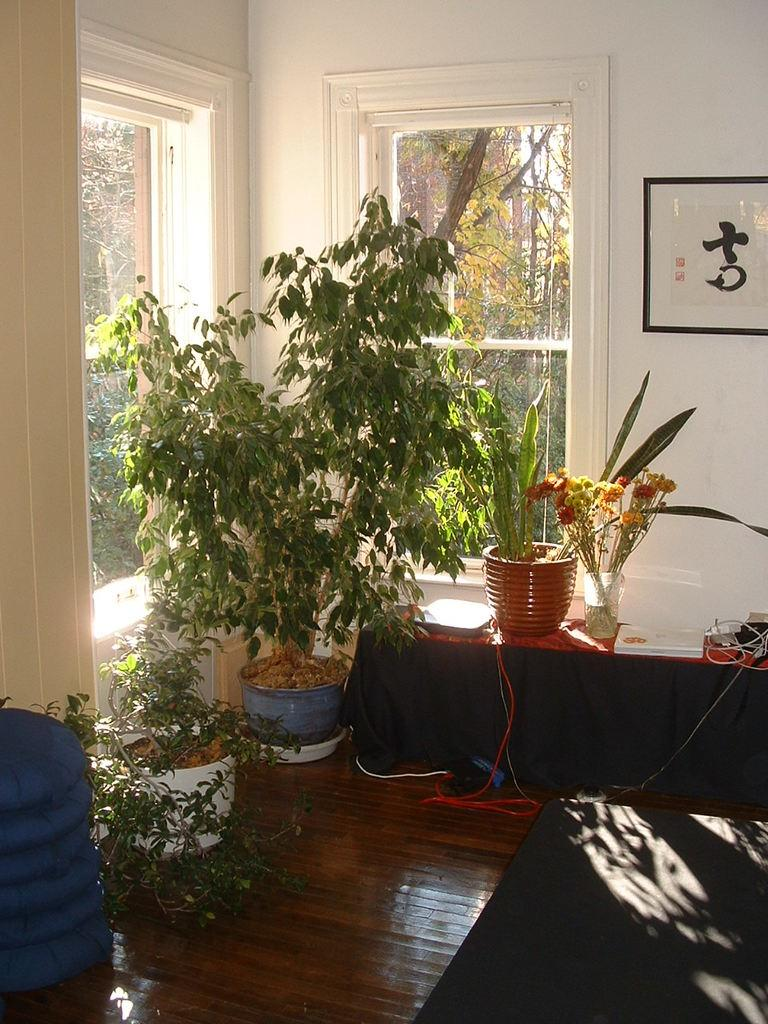What type of living organisms can be seen in the image? Plants can be seen in the image. What is located at the bottom of the image? There is a mat at the bottom of the image. What is a prominent feature in the background of the image? There is a wall in the image. How many glass windows are visible in the image? There are two glass windows in the image. What type of object is used for displaying photos in the image? There is a photo frame in the image. What type of advice does the dad give in the image? There is no dad present in the image, so it is not possible to answer that question. 